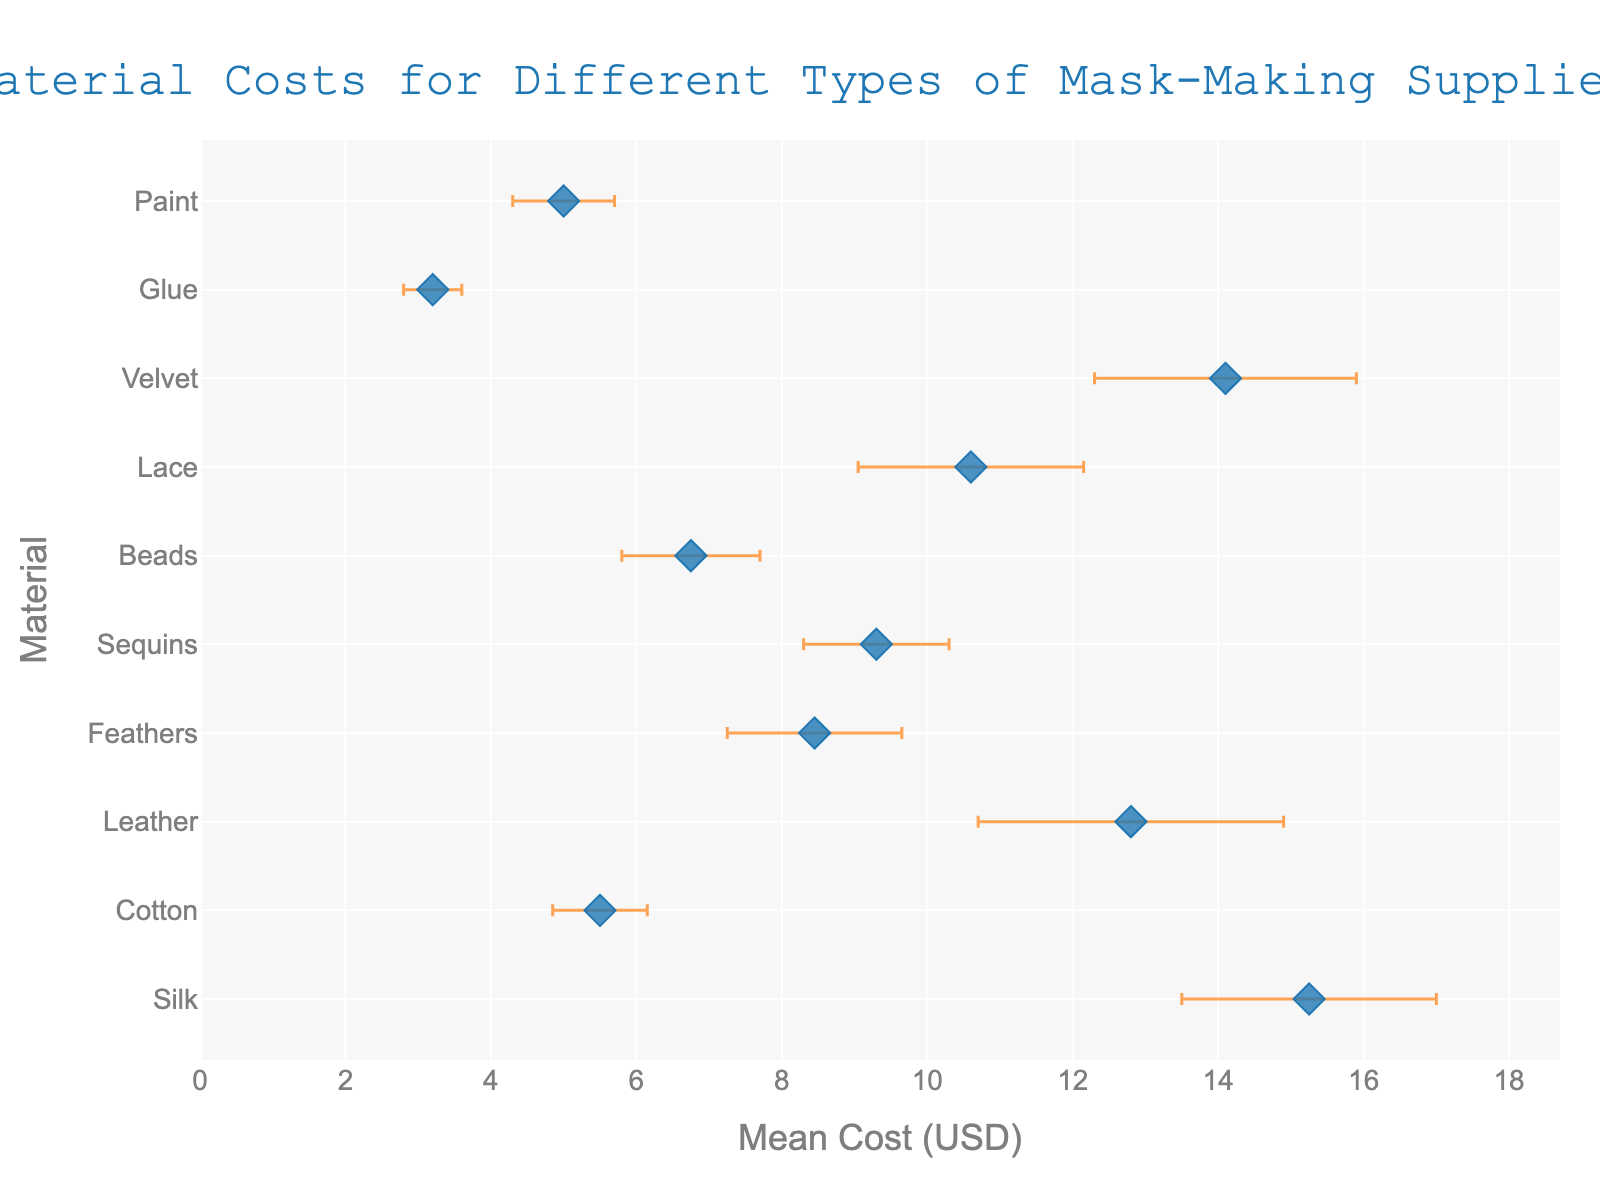What is the title of the figure? The title is located at the top of the figure, which usually provides a brief description of the visualized data.
Answer: Material Costs for Different Types of Mask-Making Supplies What material has the highest mean cost? By observing the x-axis, we can identify which material's marker is furthest to the right.
Answer: Silk What material has the lowest mean cost? To find this material, look for the marker that is furthest to the left on the x-axis.
Answer: Glue Which material has the largest error bar? The largest error bar will have the longest horizontal line extending from the marker.
Answer: Leather What is the difference in mean cost between Silk and Cotton? The mean cost of Silk is 15.25 USD and that of Cotton is 5.50 USD. Subtract the latter from the former.
Answer: 9.75 USD Which material has a higher mean cost, Sequins or Velvet? Compare the x-axis positions of the markers for Sequins and Velvet.
Answer: Velvet What is the total range of mean costs displayed on the x-axis? Identify the minimum and maximum mean costs and compute the difference, 15.25 USD (Silk) - 3.20 USD (Glue).
Answer: 12.05 USD How does the mean cost of Beads compare to Paint? Look at the positions of the Beads and Paint markers along the x-axis - Beads is to the right of Paint.
Answer: Beads is higher If a material has a mean cost below 8 USD, what else can you infer about its error bar's contribution to its total cost range? The error bar's range will be less significant compared to the materials with higher mean costs due to their typically smaller standard deviations.
Answer: Smaller contribution What is the mean cost of the material with the smallest standard deviation? Find the material with the smallest error bar (Glue) and note its mean cost.
Answer: 3.20 USD 